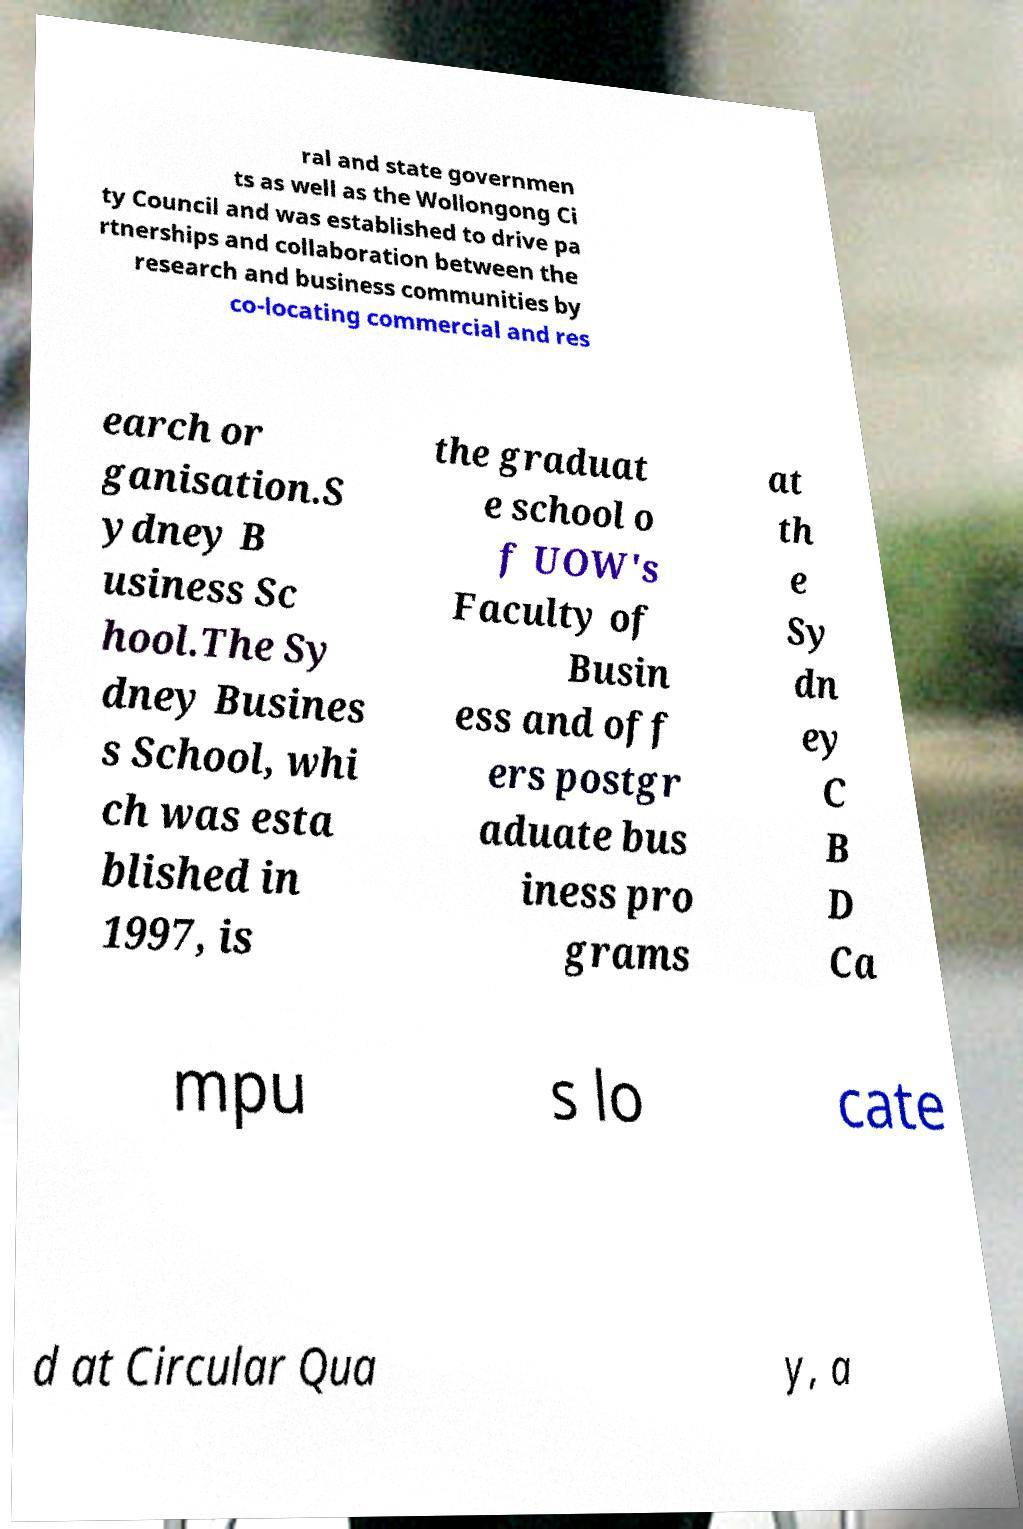Please read and relay the text visible in this image. What does it say? ral and state governmen ts as well as the Wollongong Ci ty Council and was established to drive pa rtnerships and collaboration between the research and business communities by co-locating commercial and res earch or ganisation.S ydney B usiness Sc hool.The Sy dney Busines s School, whi ch was esta blished in 1997, is the graduat e school o f UOW's Faculty of Busin ess and off ers postgr aduate bus iness pro grams at th e Sy dn ey C B D Ca mpu s lo cate d at Circular Qua y, a 